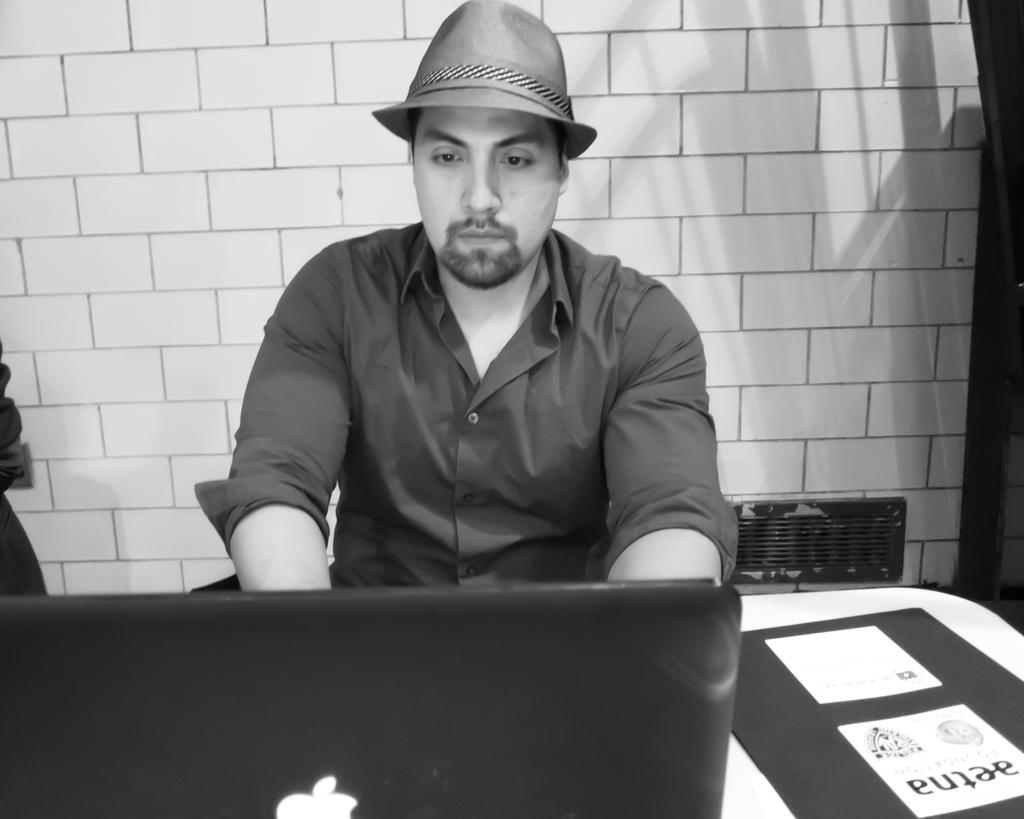In one or two sentences, can you explain what this image depicts? In this image i can see a man sitting and working on a laptop he is wearing a shirt and a cap, at the background i can see a wall. 